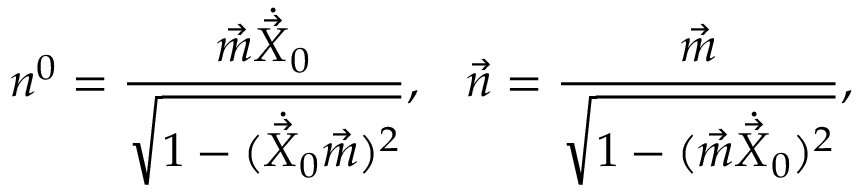<formula> <loc_0><loc_0><loc_500><loc_500>n ^ { 0 } = \frac { \vec { m } \dot { \vec { X } } _ { 0 } } { \sqrt { 1 - ( \dot { \vec { X } } _ { 0 } \vec { m } ) ^ { 2 } } } , \, \vec { n } = \frac { \vec { m } } { \sqrt { 1 - ( \vec { m } \dot { \vec { X } } _ { 0 } ) ^ { 2 } } } ,</formula> 